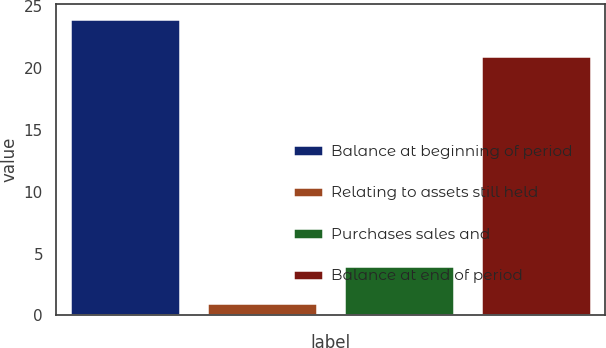<chart> <loc_0><loc_0><loc_500><loc_500><bar_chart><fcel>Balance at beginning of period<fcel>Relating to assets still held<fcel>Purchases sales and<fcel>Balance at end of period<nl><fcel>24<fcel>1<fcel>4<fcel>21<nl></chart> 